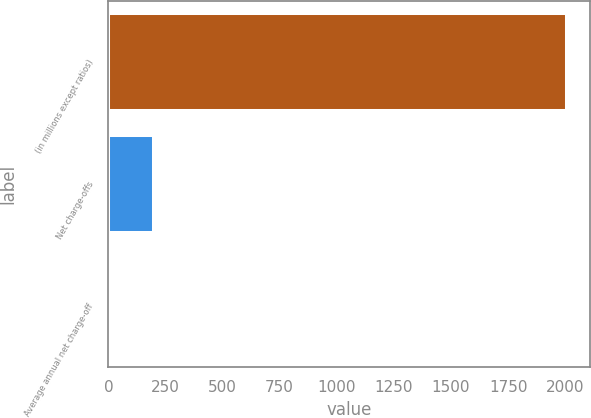<chart> <loc_0><loc_0><loc_500><loc_500><bar_chart><fcel>(in millions except ratios)<fcel>Net charge-offs<fcel>Average annual net charge-off<nl><fcel>2007<fcel>200.74<fcel>0.04<nl></chart> 